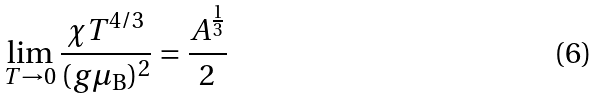<formula> <loc_0><loc_0><loc_500><loc_500>\lim _ { T \rightarrow 0 } \frac { \chi T ^ { 4 / 3 } } { ( g \mu _ { \text {B} } ) ^ { 2 } } & = \frac { A ^ { \frac { 1 } { 3 } } } { 2 }</formula> 